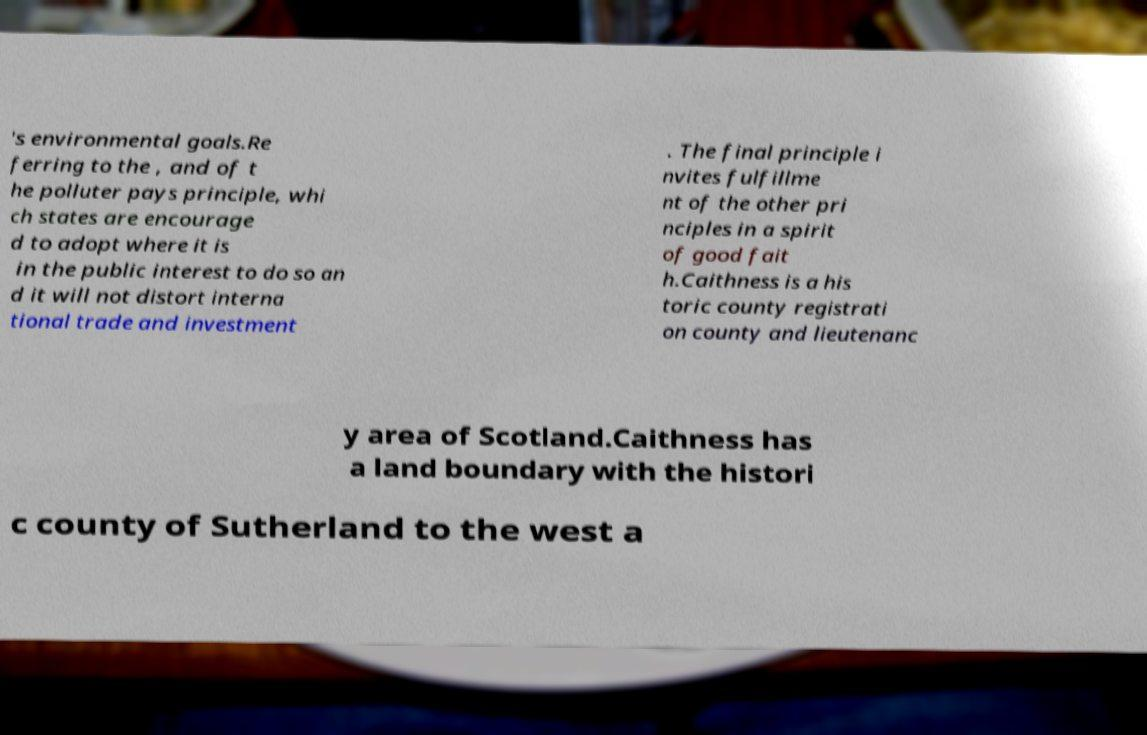Could you extract and type out the text from this image? 's environmental goals.Re ferring to the , and of t he polluter pays principle, whi ch states are encourage d to adopt where it is in the public interest to do so an d it will not distort interna tional trade and investment . The final principle i nvites fulfillme nt of the other pri nciples in a spirit of good fait h.Caithness is a his toric county registrati on county and lieutenanc y area of Scotland.Caithness has a land boundary with the histori c county of Sutherland to the west a 